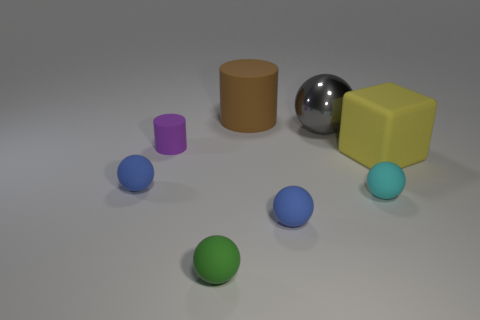Is the number of tiny gray matte objects greater than the number of small matte things?
Your answer should be very brief. No. Does the brown cylinder have the same material as the green ball on the left side of the tiny cyan matte thing?
Keep it short and to the point. Yes. How many purple rubber things are in front of the object in front of the blue sphere right of the small green rubber object?
Provide a short and direct response. 0. Are there fewer big metal objects that are to the left of the tiny purple cylinder than big cylinders right of the big yellow thing?
Your answer should be compact. No. How many other things are made of the same material as the big cylinder?
Provide a short and direct response. 6. What material is the brown thing that is the same size as the yellow matte object?
Make the answer very short. Rubber. What number of blue things are either tiny shiny objects or cylinders?
Ensure brevity in your answer.  0. What is the color of the rubber object that is both on the left side of the tiny green thing and in front of the big block?
Your answer should be compact. Blue. Is the material of the blue ball that is on the right side of the tiny purple object the same as the tiny blue sphere on the left side of the large brown cylinder?
Provide a succinct answer. Yes. Are there more tiny green balls that are behind the large rubber cylinder than big rubber things on the left side of the rubber cube?
Your response must be concise. No. 